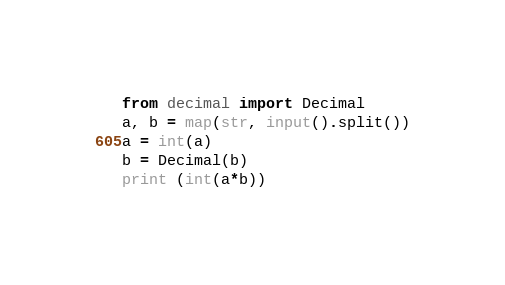Convert code to text. <code><loc_0><loc_0><loc_500><loc_500><_Python_>from decimal import Decimal
a, b = map(str, input().split())
a = int(a)
b = Decimal(b)
print (int(a*b))</code> 